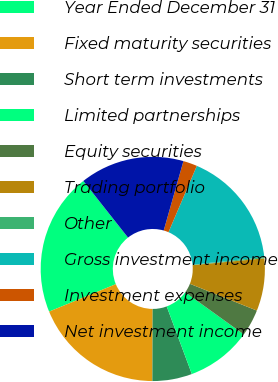<chart> <loc_0><loc_0><loc_500><loc_500><pie_chart><fcel>Year Ended December 31<fcel>Fixed maturity securities<fcel>Short term investments<fcel>Limited partnerships<fcel>Equity securities<fcel>Trading portfolio<fcel>Other<fcel>Gross investment income<fcel>Investment expenses<fcel>Net investment income<nl><fcel>20.58%<fcel>18.73%<fcel>5.72%<fcel>9.41%<fcel>3.87%<fcel>7.57%<fcel>0.18%<fcel>16.88%<fcel>2.02%<fcel>15.04%<nl></chart> 